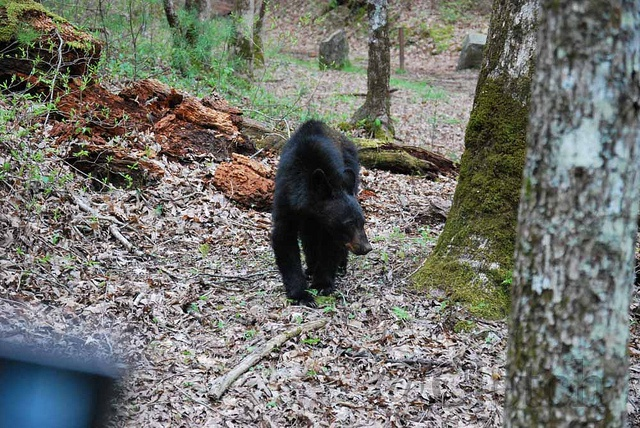Describe the objects in this image and their specific colors. I can see a bear in olive, black, gray, and darkblue tones in this image. 